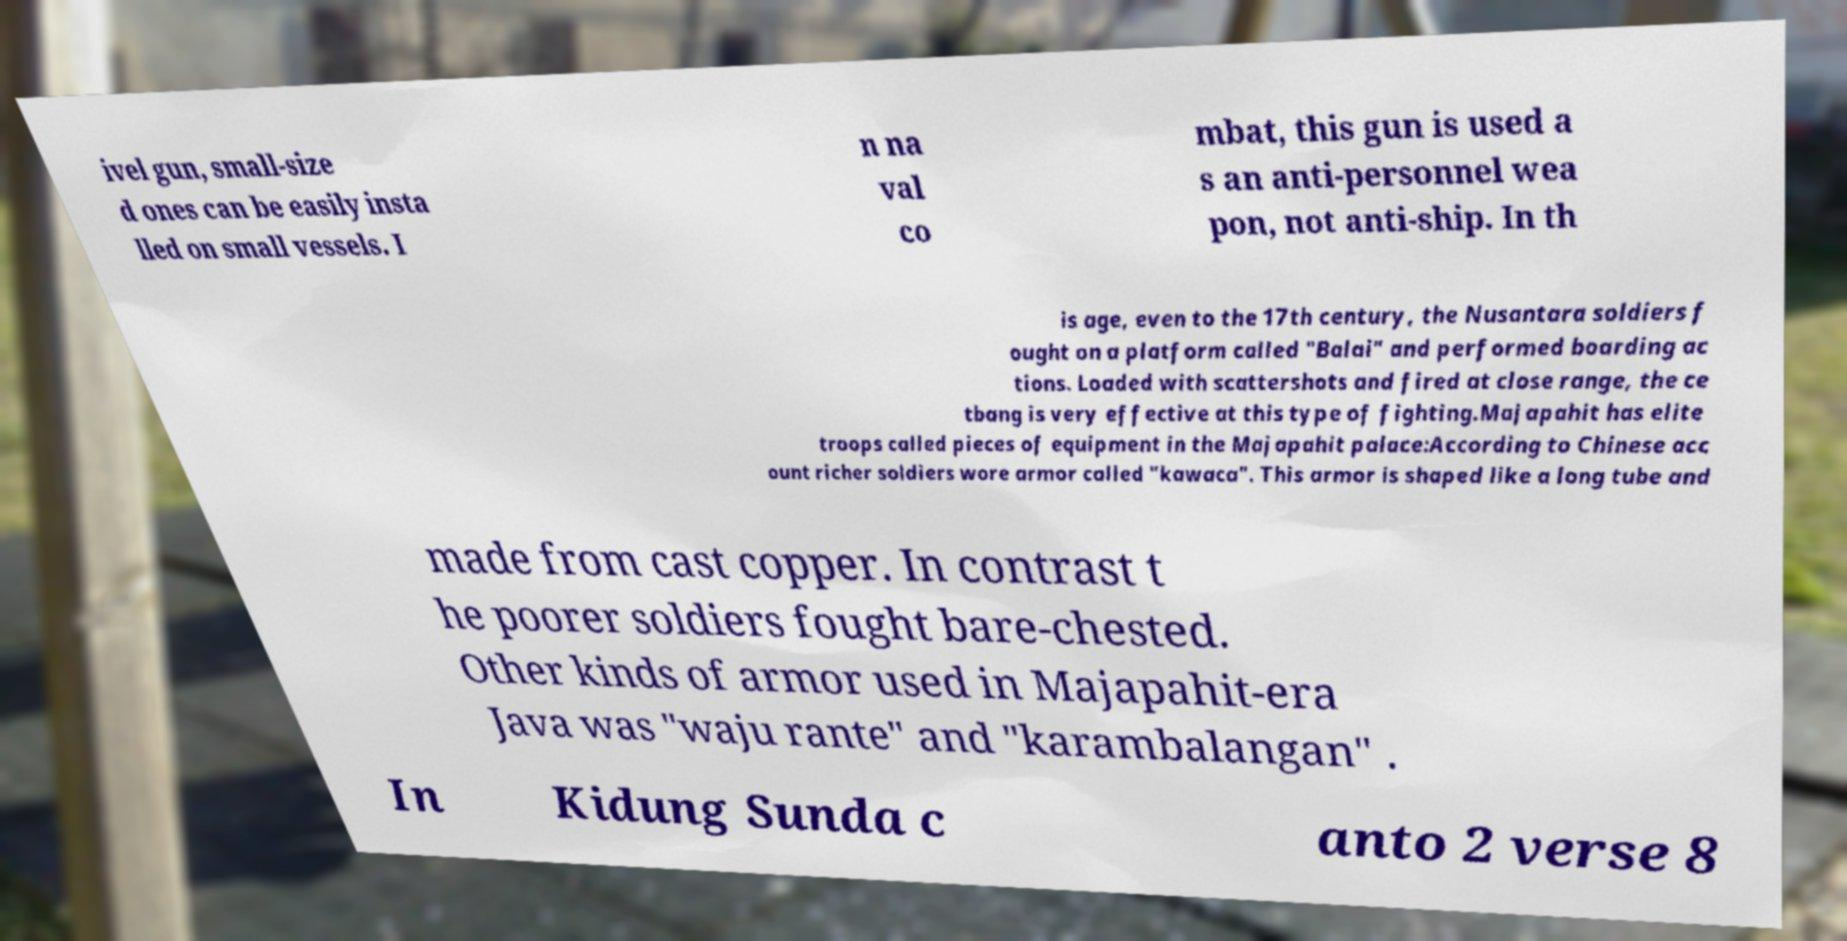Can you read and provide the text displayed in the image?This photo seems to have some interesting text. Can you extract and type it out for me? ivel gun, small-size d ones can be easily insta lled on small vessels. I n na val co mbat, this gun is used a s an anti-personnel wea pon, not anti-ship. In th is age, even to the 17th century, the Nusantara soldiers f ought on a platform called "Balai" and performed boarding ac tions. Loaded with scattershots and fired at close range, the ce tbang is very effective at this type of fighting.Majapahit has elite troops called pieces of equipment in the Majapahit palace:According to Chinese acc ount richer soldiers wore armor called "kawaca". This armor is shaped like a long tube and made from cast copper. In contrast t he poorer soldiers fought bare-chested. Other kinds of armor used in Majapahit-era Java was "waju rante" and "karambalangan" . In Kidung Sunda c anto 2 verse 8 